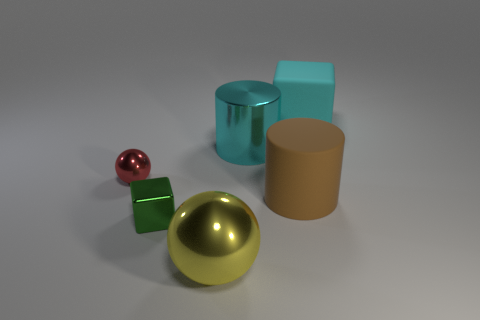Add 4 cylinders. How many objects exist? 10 Subtract all blocks. How many objects are left? 4 Subtract 0 blue cylinders. How many objects are left? 6 Subtract all cyan matte objects. Subtract all cyan rubber things. How many objects are left? 4 Add 1 tiny green cubes. How many tiny green cubes are left? 2 Add 3 blocks. How many blocks exist? 5 